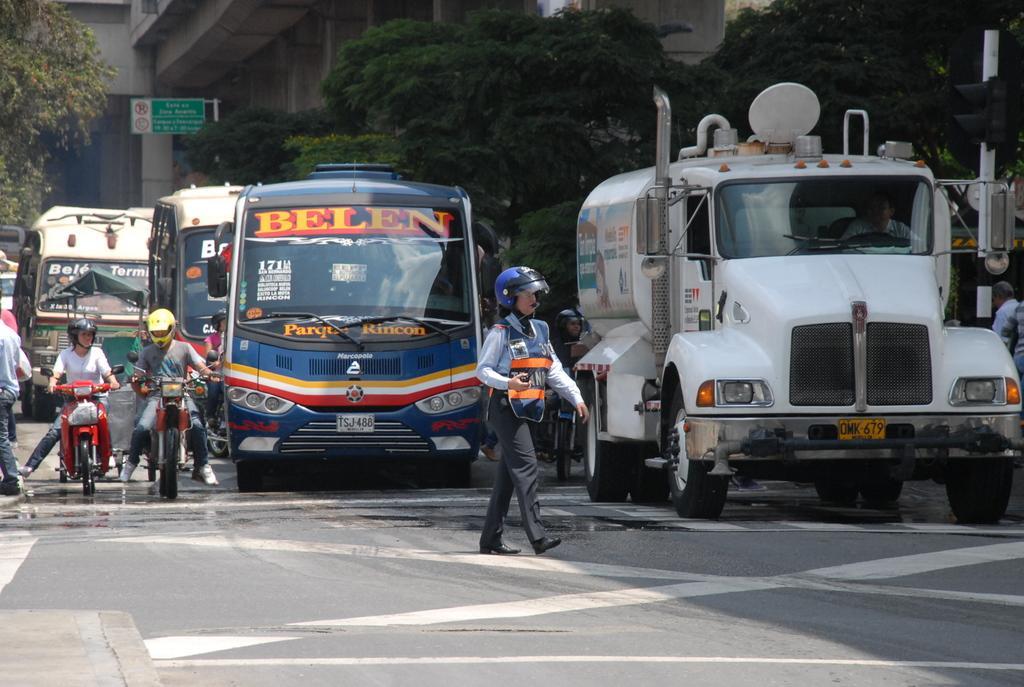Could you give a brief overview of what you see in this image? Here in this picture we can see a truck and number of buses present on the road over there and in the front we can see a woman walking on the road with helmet and apron on her and we can also see people sitting on motor bike present over there with helmets on them and behind them we can see trees present all over there and we can see sign boards also present over there. 